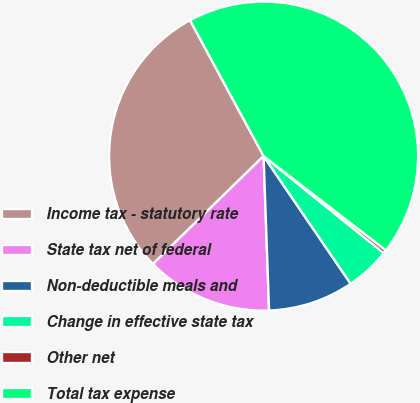Convert chart. <chart><loc_0><loc_0><loc_500><loc_500><pie_chart><fcel>Income tax - statutory rate<fcel>State tax net of federal<fcel>Non-deductible meals and<fcel>Change in effective state tax<fcel>Other net<fcel>Total tax expense<nl><fcel>29.4%<fcel>13.26%<fcel>8.96%<fcel>4.66%<fcel>0.36%<fcel>43.35%<nl></chart> 